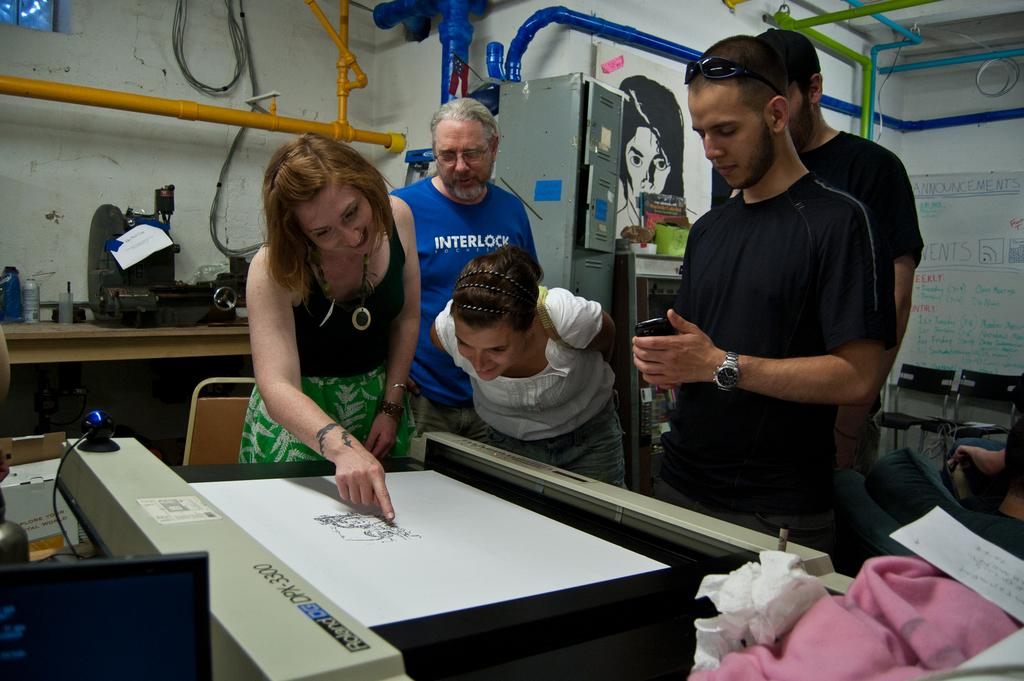How many people are in the image? There is a group of people in the image, but the exact number is not specified. What are the people looking at in the image? The people are looking at a paper in the image. What is depicted on the paper? The paper has an image on it. What else can be seen around the group of people? There are objects around the group of people, but their specific nature is not mentioned. What type of spark can be seen coming from the paper in the image? There is no spark present in the image; the people are simply looking at a paper with an image on it. 